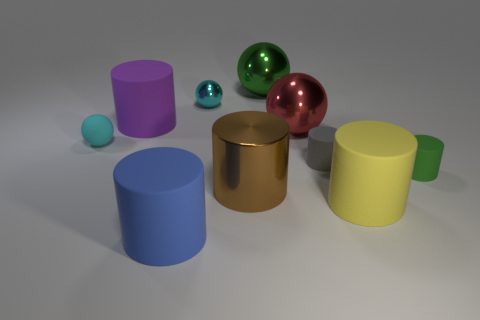Subtract all green cylinders. How many cylinders are left? 5 Subtract all green matte cylinders. How many cylinders are left? 5 Subtract all purple cylinders. Subtract all gray spheres. How many cylinders are left? 5 Subtract all balls. How many objects are left? 6 Subtract all large blue rubber spheres. Subtract all green balls. How many objects are left? 9 Add 3 small balls. How many small balls are left? 5 Add 4 large gray cubes. How many large gray cubes exist? 4 Subtract 0 red cubes. How many objects are left? 10 